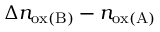Convert formula to latex. <formula><loc_0><loc_0><loc_500><loc_500>\Delta n _ { o x ( B ) } - n _ { o x ( A ) }</formula> 